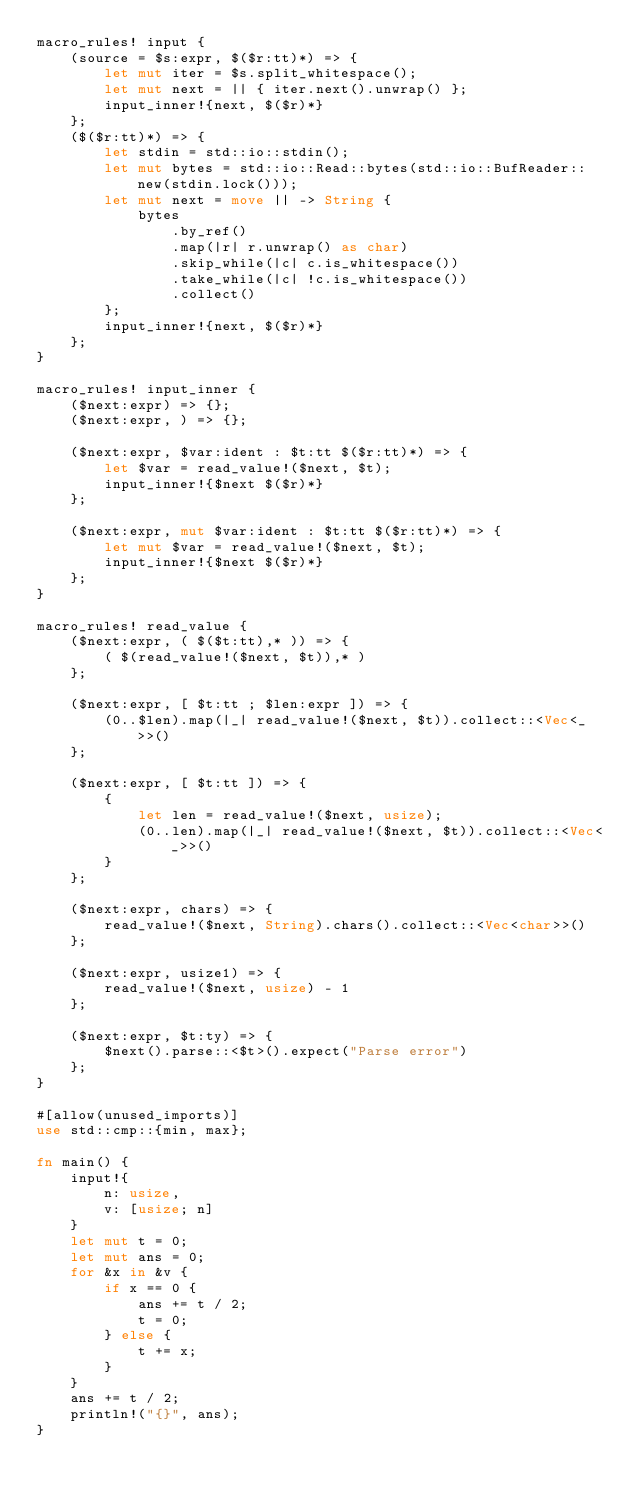Convert code to text. <code><loc_0><loc_0><loc_500><loc_500><_Rust_>macro_rules! input {
    (source = $s:expr, $($r:tt)*) => {
        let mut iter = $s.split_whitespace();
        let mut next = || { iter.next().unwrap() };
        input_inner!{next, $($r)*}
    };
    ($($r:tt)*) => {
        let stdin = std::io::stdin();
        let mut bytes = std::io::Read::bytes(std::io::BufReader::new(stdin.lock()));
        let mut next = move || -> String {
            bytes
                .by_ref()
                .map(|r| r.unwrap() as char)
                .skip_while(|c| c.is_whitespace())
                .take_while(|c| !c.is_whitespace())
                .collect()
        };
        input_inner!{next, $($r)*}
    };
}

macro_rules! input_inner {
    ($next:expr) => {};
    ($next:expr, ) => {};

    ($next:expr, $var:ident : $t:tt $($r:tt)*) => {
        let $var = read_value!($next, $t);
        input_inner!{$next $($r)*}
    };

    ($next:expr, mut $var:ident : $t:tt $($r:tt)*) => {
        let mut $var = read_value!($next, $t);
        input_inner!{$next $($r)*}
    };
}

macro_rules! read_value {
    ($next:expr, ( $($t:tt),* )) => {
        ( $(read_value!($next, $t)),* )
    };

    ($next:expr, [ $t:tt ; $len:expr ]) => {
        (0..$len).map(|_| read_value!($next, $t)).collect::<Vec<_>>()
    };

    ($next:expr, [ $t:tt ]) => {
        {
            let len = read_value!($next, usize);
            (0..len).map(|_| read_value!($next, $t)).collect::<Vec<_>>()
        }
    };

    ($next:expr, chars) => {
        read_value!($next, String).chars().collect::<Vec<char>>()
    };

    ($next:expr, usize1) => {
        read_value!($next, usize) - 1
    };

    ($next:expr, $t:ty) => {
        $next().parse::<$t>().expect("Parse error")
    };
}

#[allow(unused_imports)]
use std::cmp::{min, max};

fn main() {
    input!{
        n: usize,
        v: [usize; n]
    }
    let mut t = 0;
    let mut ans = 0;
    for &x in &v {
        if x == 0 {
            ans += t / 2;
            t = 0;
        } else {
            t += x;
        }
    }
    ans += t / 2;
    println!("{}", ans);
}
</code> 